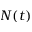Convert formula to latex. <formula><loc_0><loc_0><loc_500><loc_500>N ( t )</formula> 